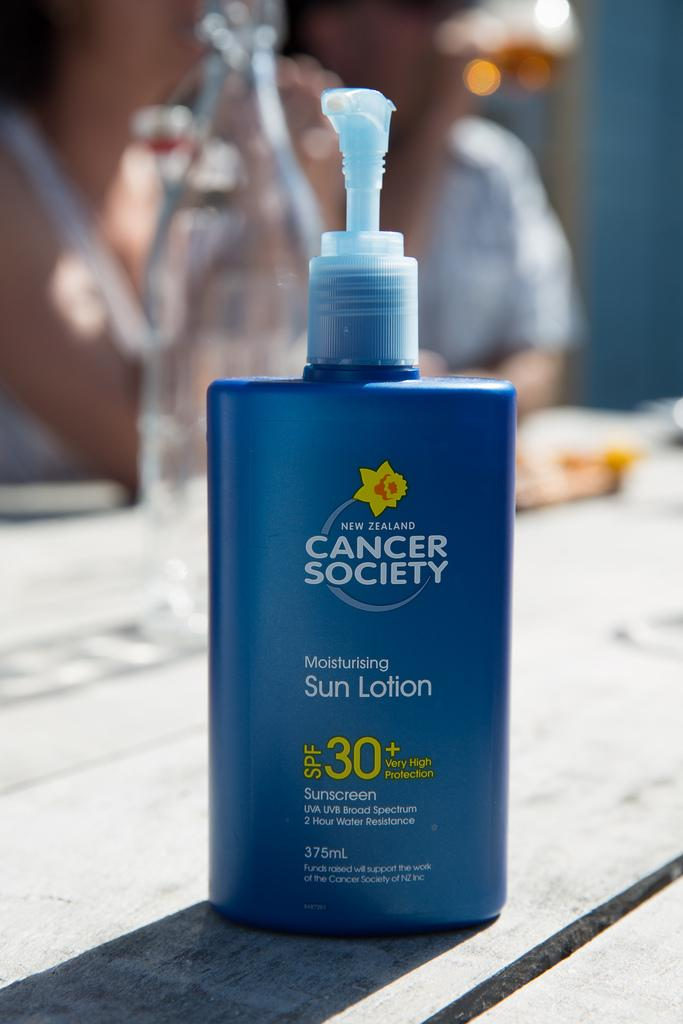What is the main object in the image? There is a bottle of lotion in the image. Where is the bottle of lotion placed? The bottle of lotion is placed on a wooden table. What other object can be seen on the wooden table? There is a jar on the wooden table. What can be seen in the background of the image? There is a person visible in the background of the image, but it is blurry, and there is a wall in the background of the image. What type of faucet is visible in the image? There is no faucet present in the image. What kind of pot is being used by the person in the image? There is no pot visible in the image, and the person in the background is blurry, so it is impossible to determine what they might be using. 